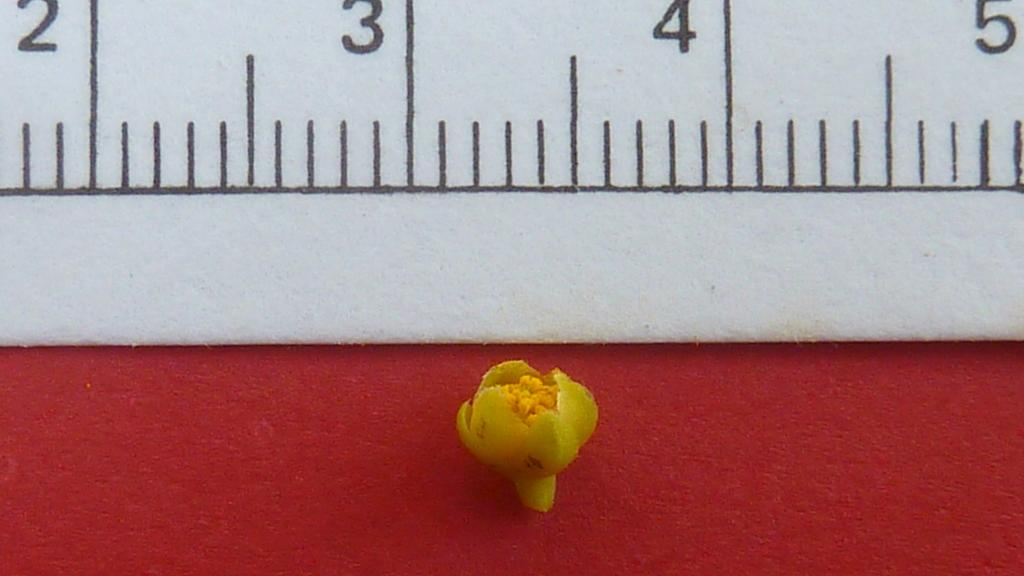<image>
Relay a brief, clear account of the picture shown. A tiny flower next to a ruler that measures it at a half inch. 